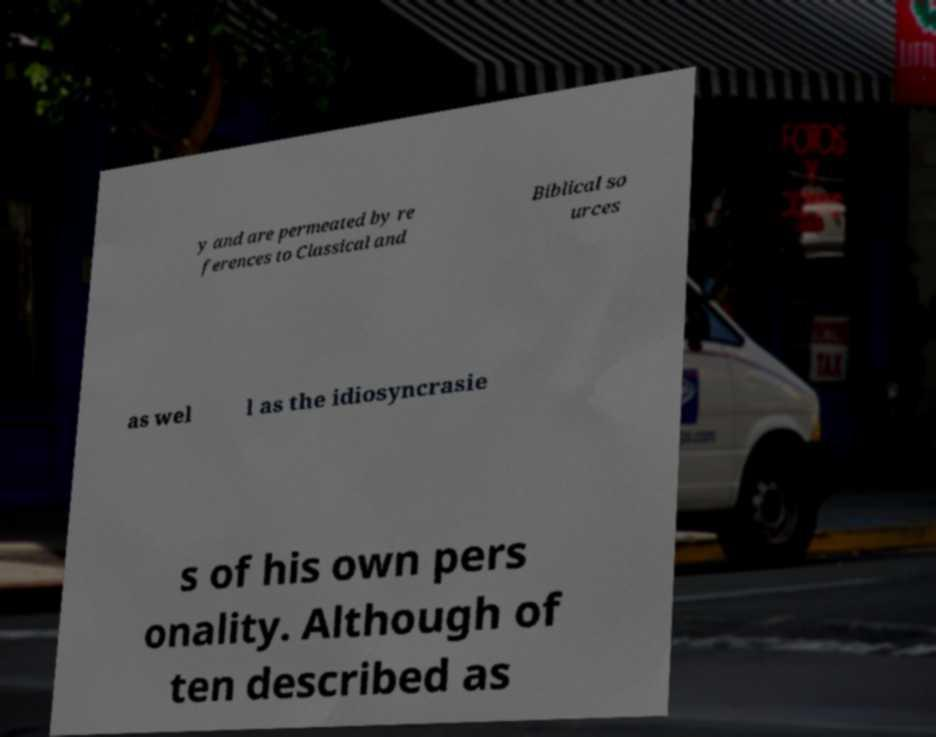Please read and relay the text visible in this image. What does it say? y and are permeated by re ferences to Classical and Biblical so urces as wel l as the idiosyncrasie s of his own pers onality. Although of ten described as 